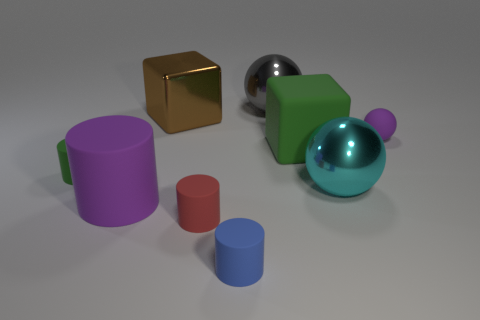Subtract all green matte cylinders. How many cylinders are left? 3 Subtract all purple balls. How many balls are left? 2 Subtract all blocks. How many objects are left? 7 Subtract 2 spheres. How many spheres are left? 1 Subtract all red blocks. Subtract all cyan spheres. How many blocks are left? 2 Subtract 0 blue spheres. How many objects are left? 9 Subtract all red cylinders. How many brown blocks are left? 1 Subtract all big purple matte things. Subtract all cubes. How many objects are left? 6 Add 4 gray objects. How many gray objects are left? 5 Add 8 green shiny cylinders. How many green shiny cylinders exist? 8 